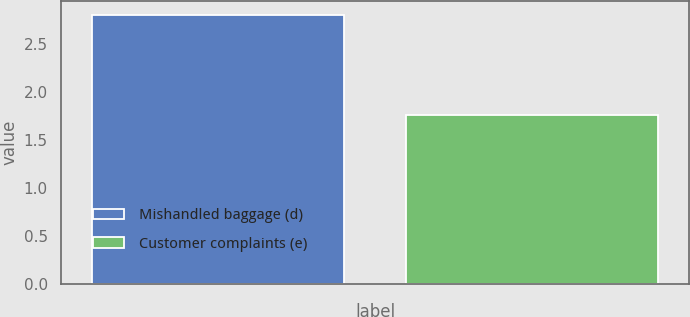Convert chart to OTSL. <chart><loc_0><loc_0><loc_500><loc_500><bar_chart><fcel>Mishandled baggage (d)<fcel>Customer complaints (e)<nl><fcel>2.8<fcel>1.76<nl></chart> 